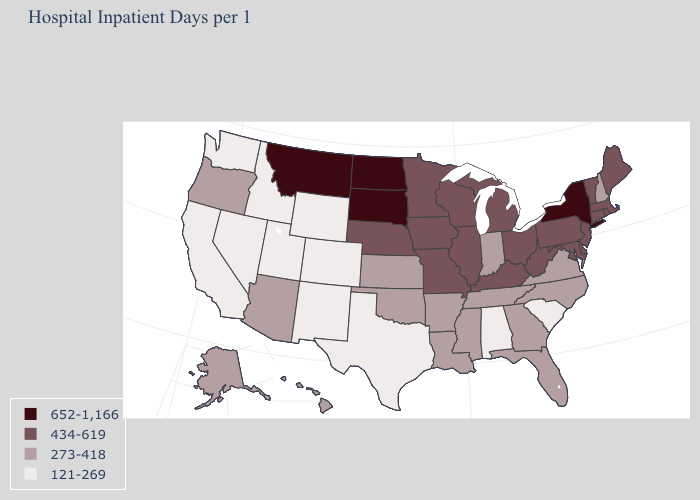Name the states that have a value in the range 121-269?
Short answer required. Alabama, California, Colorado, Idaho, Nevada, New Mexico, South Carolina, Texas, Utah, Washington, Wyoming. What is the value of Wisconsin?
Quick response, please. 434-619. What is the value of Iowa?
Answer briefly. 434-619. What is the value of Arkansas?
Write a very short answer. 273-418. Does Tennessee have the same value as South Carolina?
Keep it brief. No. Name the states that have a value in the range 273-418?
Concise answer only. Alaska, Arizona, Arkansas, Florida, Georgia, Hawaii, Indiana, Kansas, Louisiana, Mississippi, New Hampshire, North Carolina, Oklahoma, Oregon, Tennessee, Virginia. What is the value of New York?
Give a very brief answer. 652-1,166. Among the states that border Alabama , which have the highest value?
Be succinct. Florida, Georgia, Mississippi, Tennessee. What is the value of Idaho?
Quick response, please. 121-269. What is the lowest value in states that border Washington?
Short answer required. 121-269. Which states have the lowest value in the USA?
Short answer required. Alabama, California, Colorado, Idaho, Nevada, New Mexico, South Carolina, Texas, Utah, Washington, Wyoming. What is the value of Alabama?
Keep it brief. 121-269. Among the states that border Iowa , which have the highest value?
Give a very brief answer. South Dakota. How many symbols are there in the legend?
Quick response, please. 4. How many symbols are there in the legend?
Keep it brief. 4. 